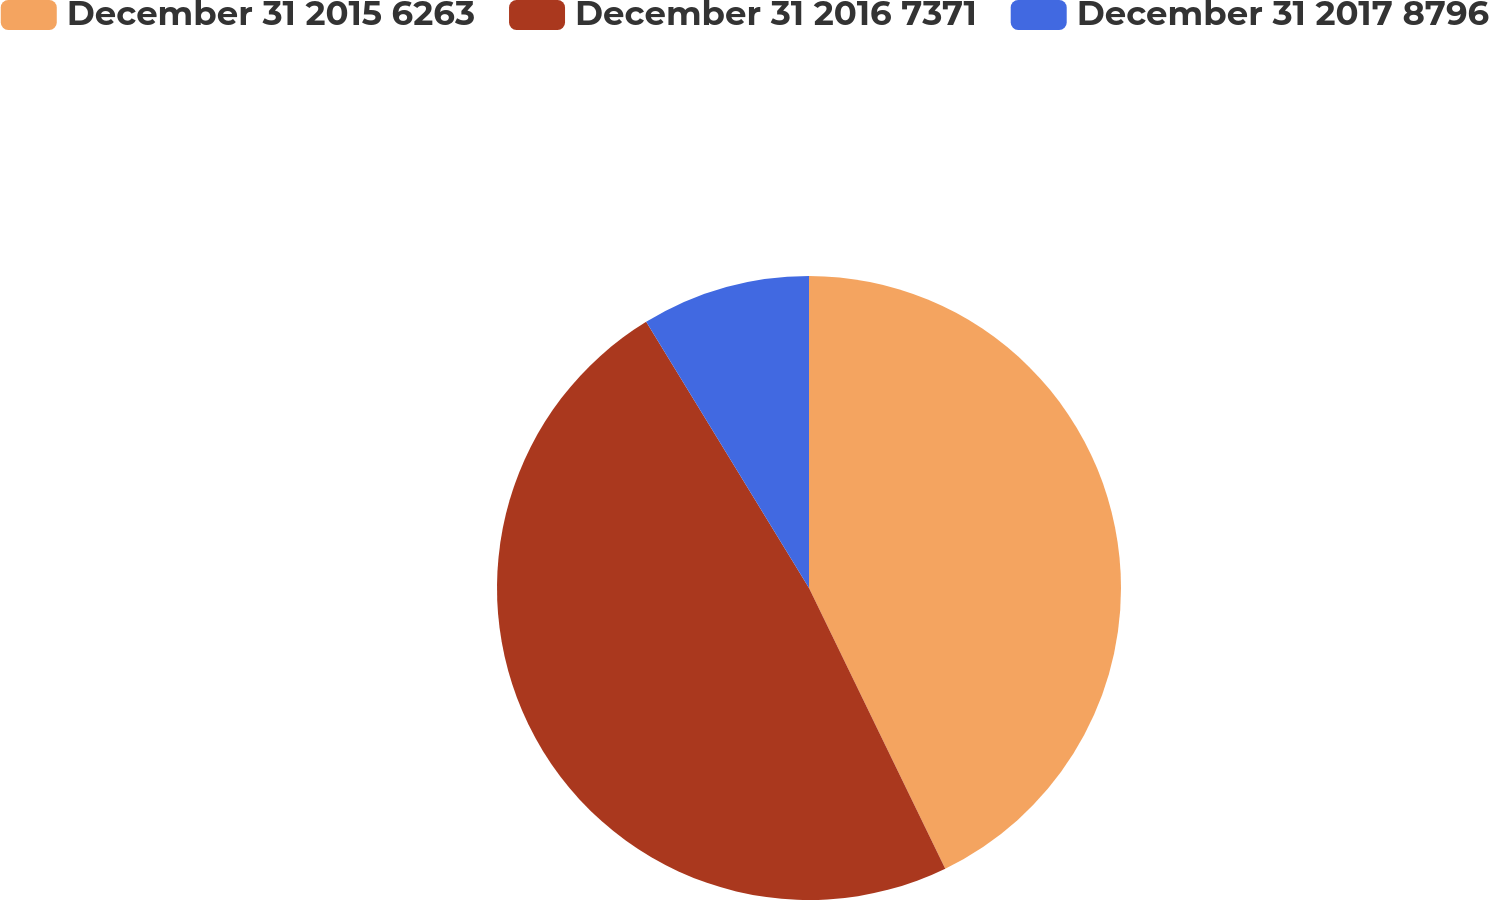Convert chart. <chart><loc_0><loc_0><loc_500><loc_500><pie_chart><fcel>December 31 2015 6263<fcel>December 31 2016 7371<fcel>December 31 2017 8796<nl><fcel>42.81%<fcel>48.46%<fcel>8.74%<nl></chart> 